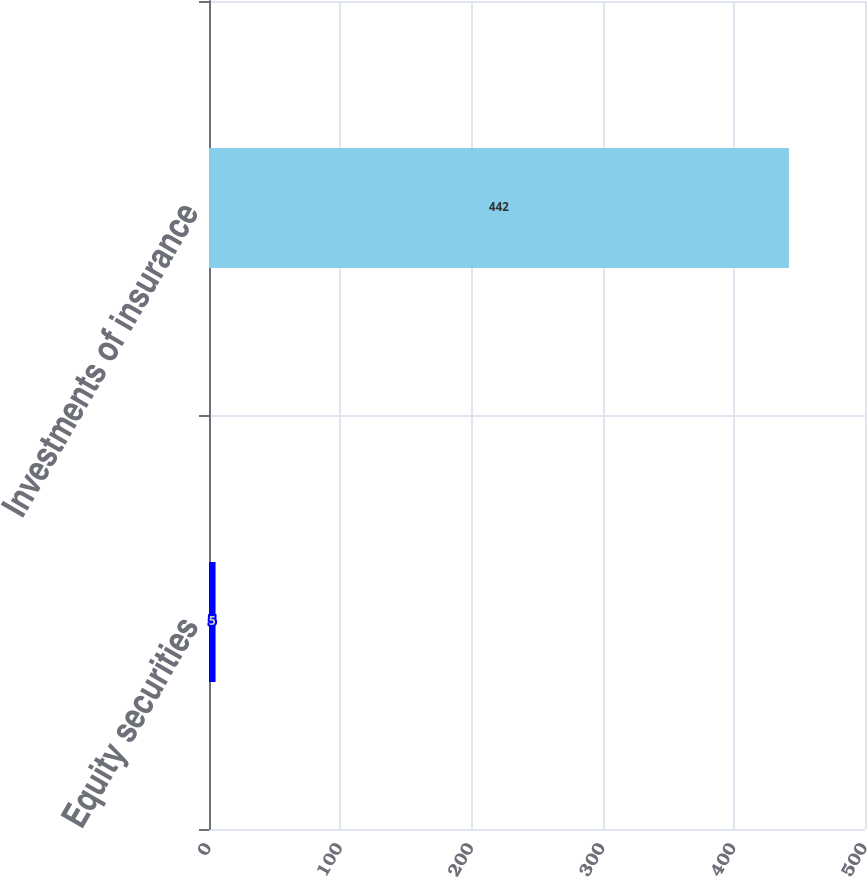Convert chart. <chart><loc_0><loc_0><loc_500><loc_500><bar_chart><fcel>Equity securities<fcel>Investments of insurance<nl><fcel>5<fcel>442<nl></chart> 